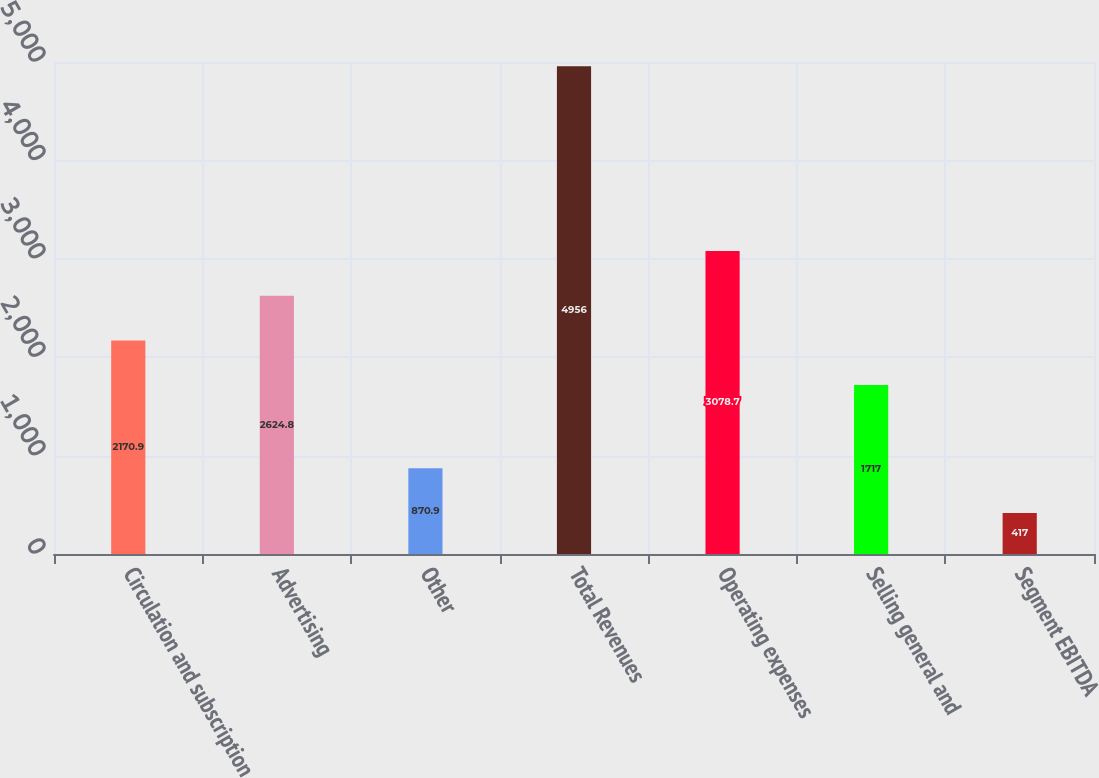<chart> <loc_0><loc_0><loc_500><loc_500><bar_chart><fcel>Circulation and subscription<fcel>Advertising<fcel>Other<fcel>Total Revenues<fcel>Operating expenses<fcel>Selling general and<fcel>Segment EBITDA<nl><fcel>2170.9<fcel>2624.8<fcel>870.9<fcel>4956<fcel>3078.7<fcel>1717<fcel>417<nl></chart> 